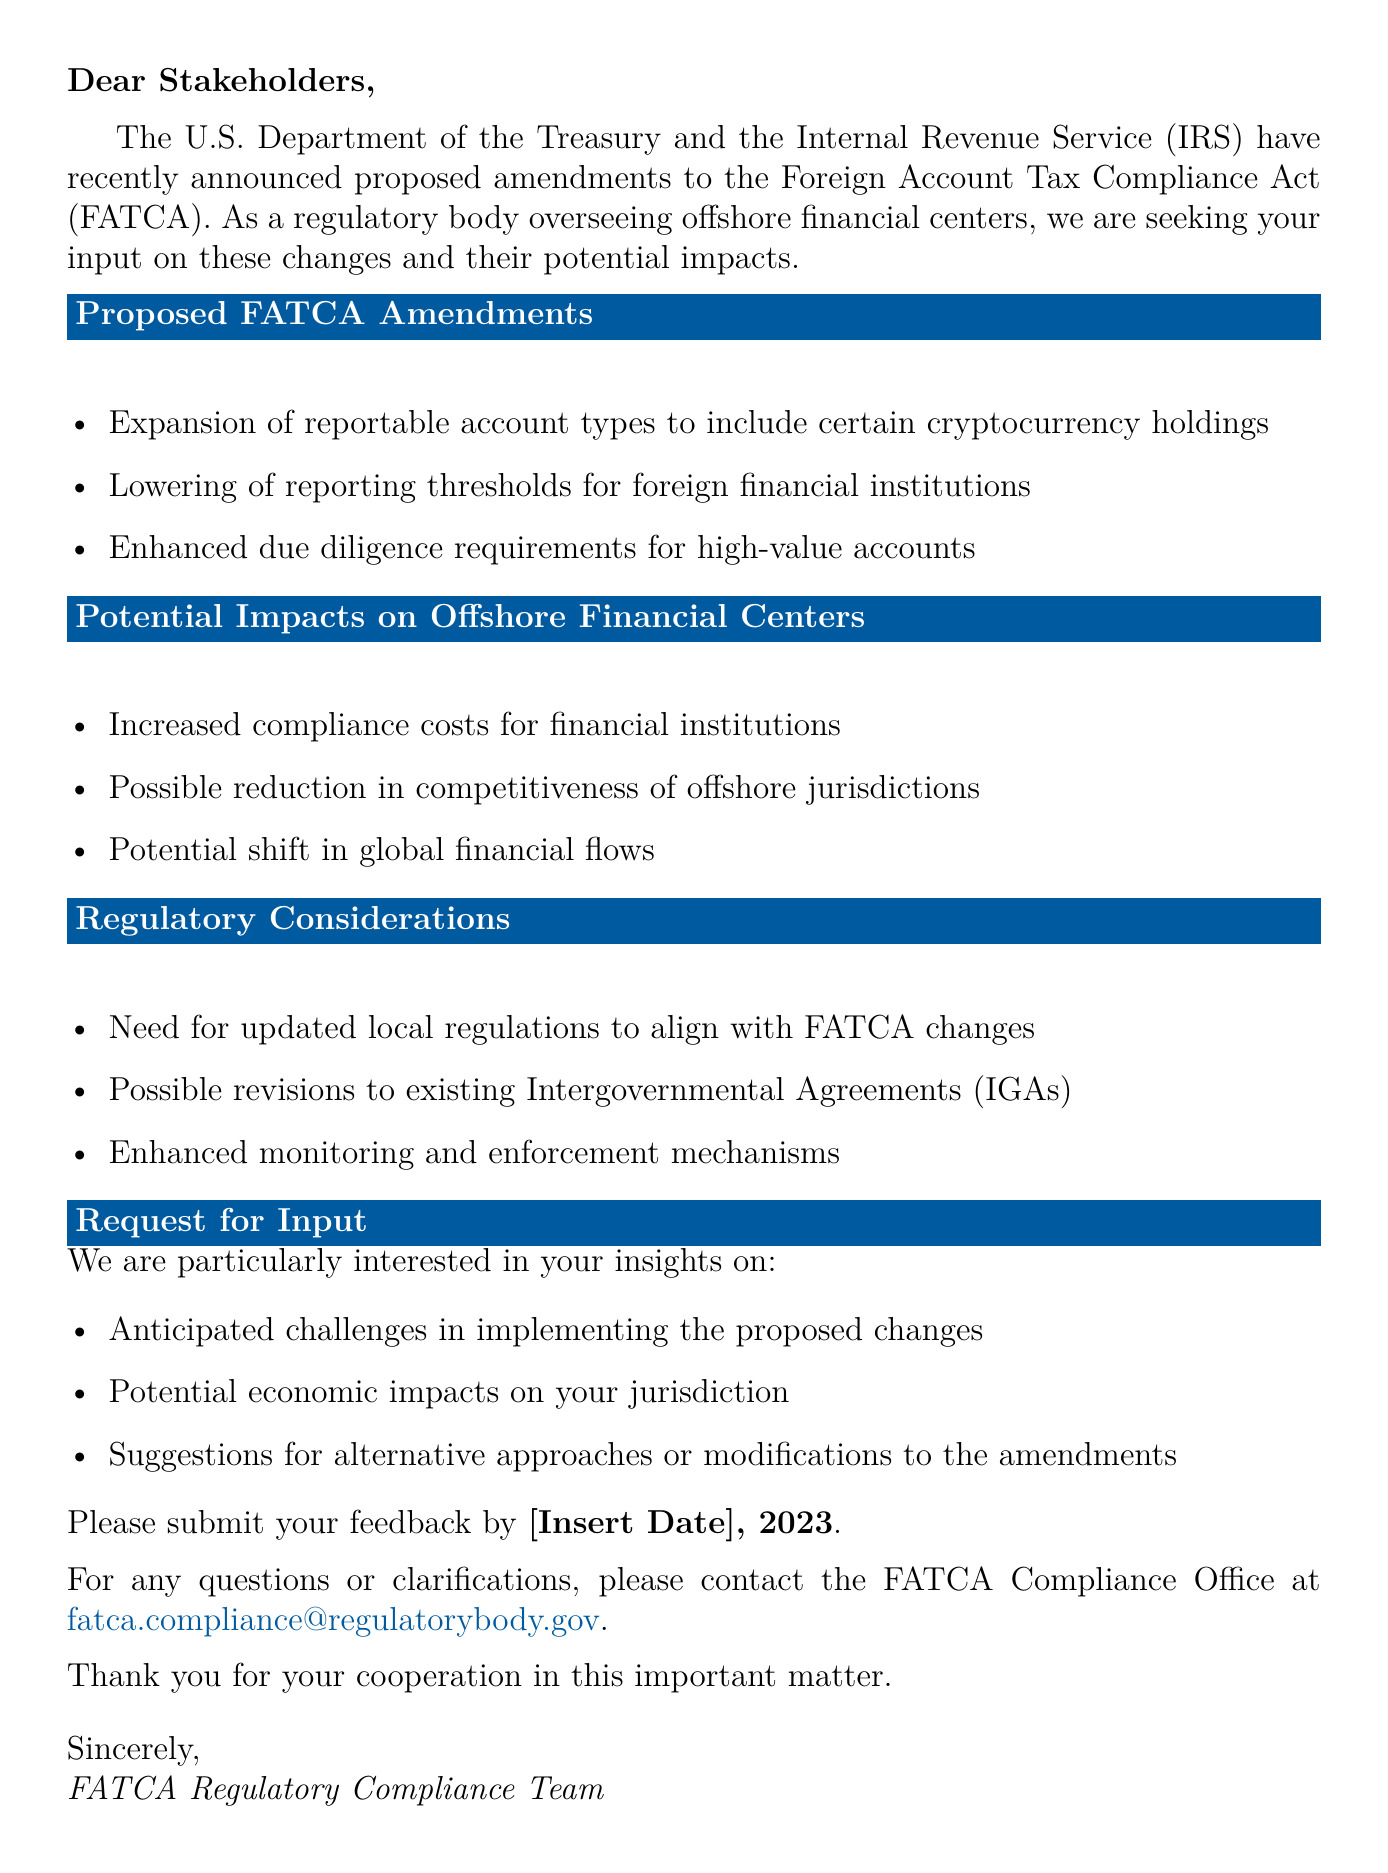What is the subject of the email? The subject of the email is stated at the beginning and pertains to proposed amendments to FATCA focusing on offshore financial centers.
Answer: Request for Input: Proposed Amendments to FATCA - Implications for Offshore Financial Centers Who issued the proposed amendments to FATCA? The email identifies the issuing bodies in the introduction section as the U.S. Department of the Treasury and the IRS.
Answer: U.S. Department of the Treasury and the Internal Revenue Service What type of account holdings are included in the proposed amendments? The proposed amendments expand reportable account types, specifically mentioning the inclusion of cryptocurrency holdings.
Answer: Cryptocurrency holdings What is the deadline for submitting feedback? The email specifies a point in time by which feedback is to be submitted, though it notes that the exact date needs to be inserted.
Answer: [Insert Date], 2023 What is one potential impact on offshore financial centers mentioned? The email lists potential impacts, one of which is increased compliance costs for financial institutions.
Answer: Increased compliance costs for financial institutions What is the primary focus of the request for input? The document states what the regulatory body is particularly interested in regarding the proposed amendments.
Answer: Anticipated challenges in implementing the proposed changes How should feedback be submitted? The document mentions a deadline for feedback but does not specify the method of submission.
Answer: Not explicitly stated What type of regulatory considerations are mentioned in the document? The document outlines certain regulatory considerations that may arise from the proposed amendments to FATCA.
Answer: Updated local regulations to align with FATCA changes 